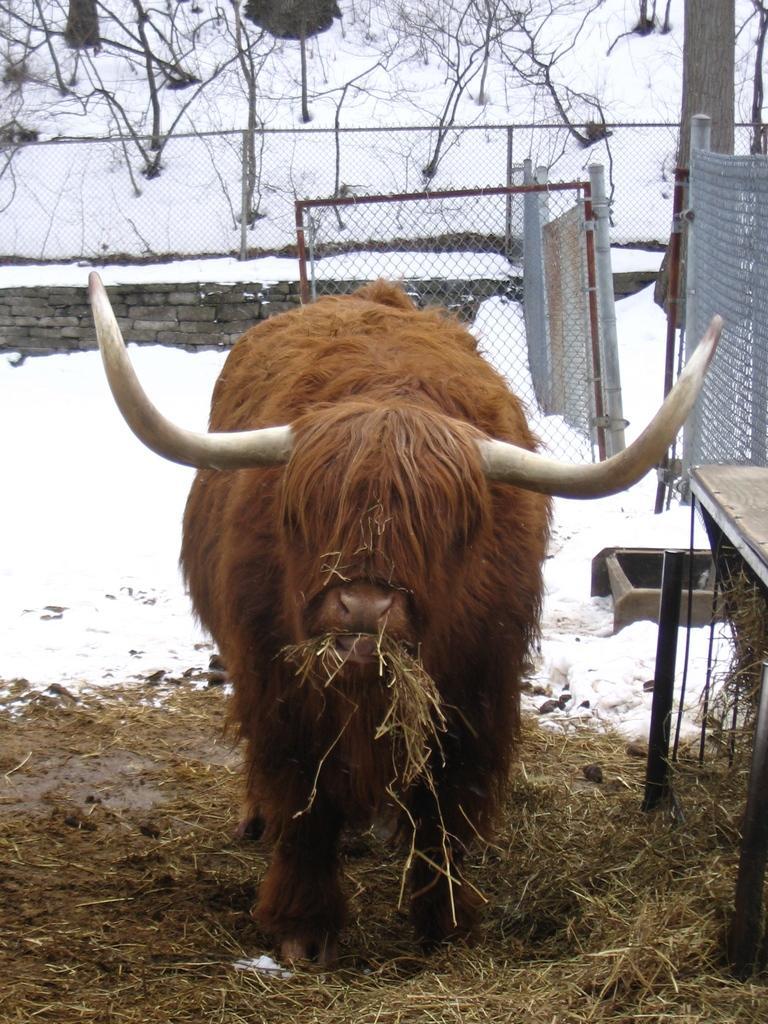Describe this image in one or two sentences. In this image we can see an animal on the ground, there is a table beside the animal, there is snow, wall, fence, gate and few trees in the background. 